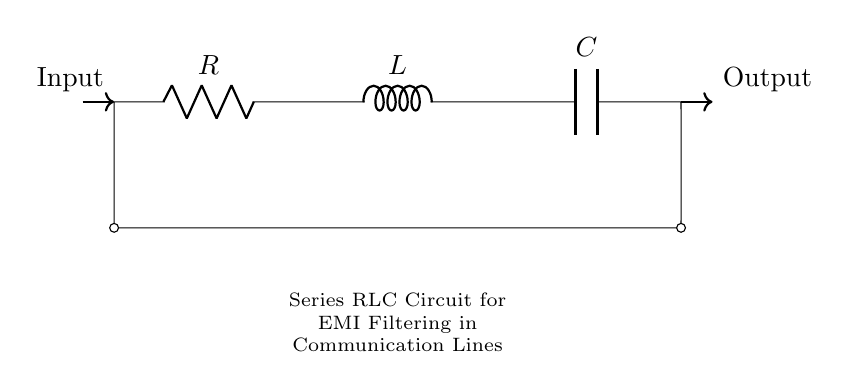What is the component labeled R? The component labeled R is a resistor that controls the current flow in the circuit.
Answer: Resistor What is the component labeled L? The component labeled L is an inductor that stores energy in a magnetic field when current passes through it.
Answer: Inductor What is the total number of components in this circuit? There are three main components: a resistor, an inductor, and a capacitor.
Answer: Three How are the components connected in this circuit? The components R, L, and C are connected in series, meaning the current flows through each component one after the other.
Answer: Series What is the function of this circuit? This circuit filters electromagnetic interference in communication lines, allowing only desired signals to pass through while reducing noise.
Answer: Filtering EMI What type of circuit is depicted here? The depicted circuit is a series RLC circuit, specifically used for filtering applications involving resistance, inductance, and capacitance connected in series.
Answer: Series RLC circuit Why might this circuit be used in communication lines? This circuit helps in eliminating unwanted noise or interference that can disrupt the clarity and reliability of communication signals.
Answer: Reducing interference 